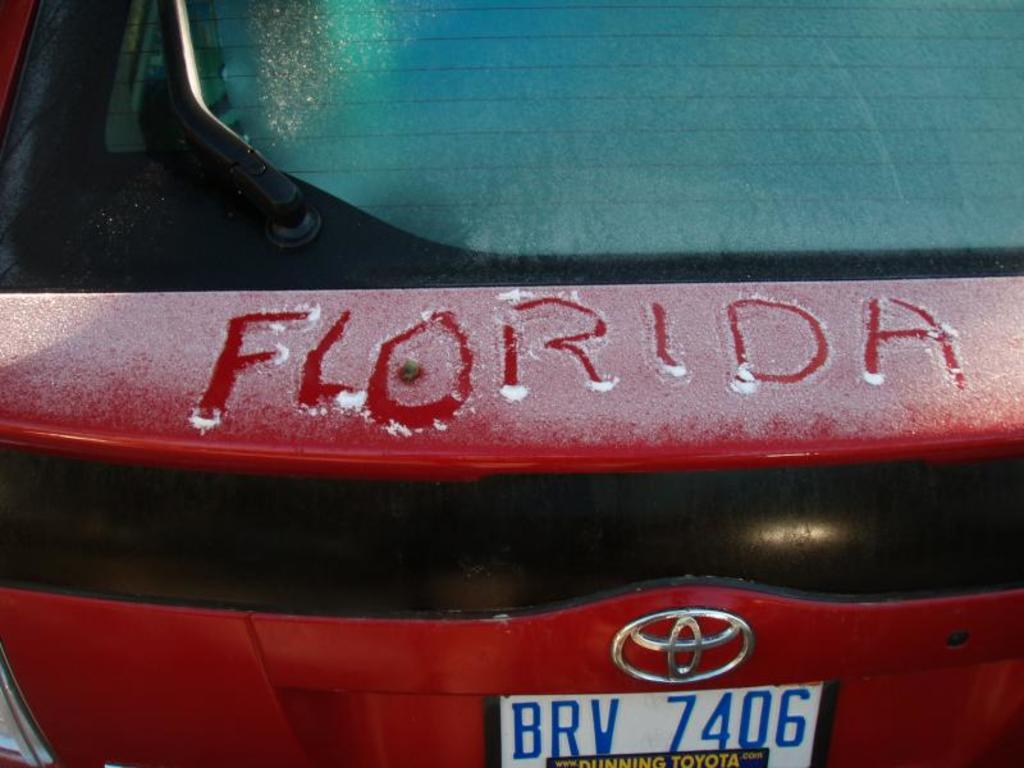<image>
Provide a brief description of the given image. Florida is scratched out of frost on a car 